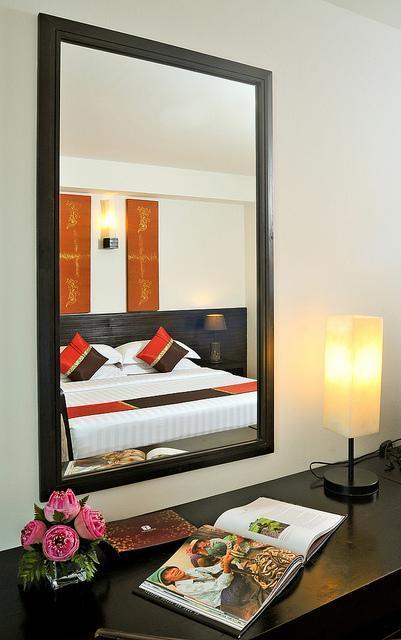How many books?
Give a very brief answer. 1. How many potted plants are there?
Give a very brief answer. 1. 